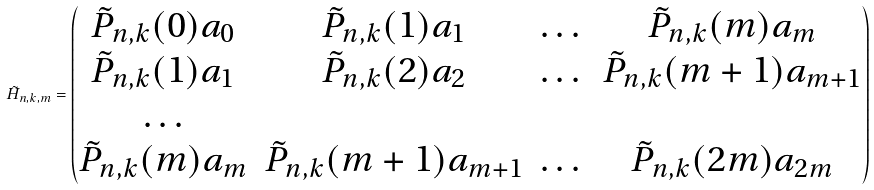Convert formula to latex. <formula><loc_0><loc_0><loc_500><loc_500>\tilde { H } _ { n , k , m } = \begin{pmatrix} \tilde { P } _ { n , k } ( 0 ) a _ { 0 } & \tilde { P } _ { n , k } ( 1 ) a _ { 1 } & \dots & \tilde { P } _ { n , k } ( m ) a _ { m } \\ \tilde { P } _ { n , k } ( 1 ) a _ { 1 } & \tilde { P } _ { n , k } ( 2 ) a _ { 2 } & \dots & \tilde { P } _ { n , k } ( m + 1 ) a _ { m + 1 } \\ \dots \\ \tilde { P } _ { n , k } ( m ) a _ { m } & \tilde { P } _ { n , k } ( m + 1 ) a _ { m + 1 } & \dots & \tilde { P } _ { n , k } ( 2 m ) a _ { 2 m } \end{pmatrix}</formula> 